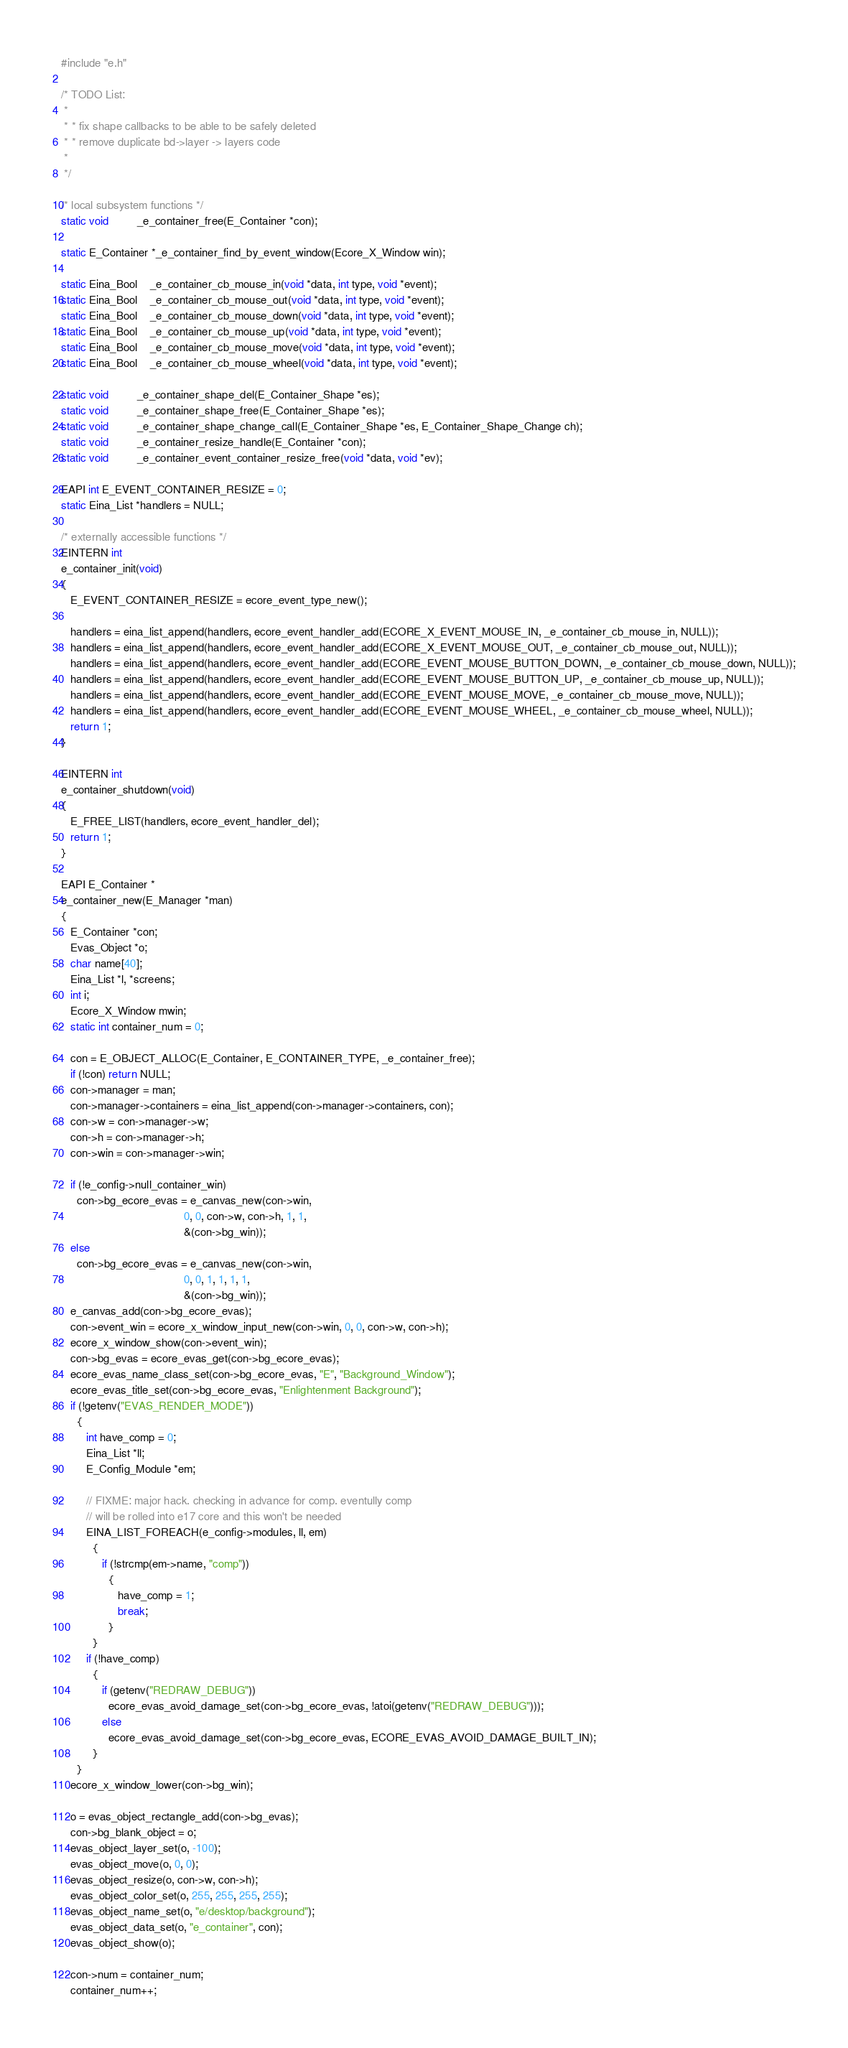Convert code to text. <code><loc_0><loc_0><loc_500><loc_500><_C_>#include "e.h"

/* TODO List:
 *
 * * fix shape callbacks to be able to be safely deleted
 * * remove duplicate bd->layer -> layers code
 *
 */

/* local subsystem functions */
static void         _e_container_free(E_Container *con);

static E_Container *_e_container_find_by_event_window(Ecore_X_Window win);

static Eina_Bool    _e_container_cb_mouse_in(void *data, int type, void *event);
static Eina_Bool    _e_container_cb_mouse_out(void *data, int type, void *event);
static Eina_Bool    _e_container_cb_mouse_down(void *data, int type, void *event);
static Eina_Bool    _e_container_cb_mouse_up(void *data, int type, void *event);
static Eina_Bool    _e_container_cb_mouse_move(void *data, int type, void *event);
static Eina_Bool    _e_container_cb_mouse_wheel(void *data, int type, void *event);

static void         _e_container_shape_del(E_Container_Shape *es);
static void         _e_container_shape_free(E_Container_Shape *es);
static void         _e_container_shape_change_call(E_Container_Shape *es, E_Container_Shape_Change ch);
static void         _e_container_resize_handle(E_Container *con);
static void         _e_container_event_container_resize_free(void *data, void *ev);

EAPI int E_EVENT_CONTAINER_RESIZE = 0;
static Eina_List *handlers = NULL;

/* externally accessible functions */
EINTERN int
e_container_init(void)
{
   E_EVENT_CONTAINER_RESIZE = ecore_event_type_new();

   handlers = eina_list_append(handlers, ecore_event_handler_add(ECORE_X_EVENT_MOUSE_IN, _e_container_cb_mouse_in, NULL));
   handlers = eina_list_append(handlers, ecore_event_handler_add(ECORE_X_EVENT_MOUSE_OUT, _e_container_cb_mouse_out, NULL));
   handlers = eina_list_append(handlers, ecore_event_handler_add(ECORE_EVENT_MOUSE_BUTTON_DOWN, _e_container_cb_mouse_down, NULL));
   handlers = eina_list_append(handlers, ecore_event_handler_add(ECORE_EVENT_MOUSE_BUTTON_UP, _e_container_cb_mouse_up, NULL));
   handlers = eina_list_append(handlers, ecore_event_handler_add(ECORE_EVENT_MOUSE_MOVE, _e_container_cb_mouse_move, NULL));
   handlers = eina_list_append(handlers, ecore_event_handler_add(ECORE_EVENT_MOUSE_WHEEL, _e_container_cb_mouse_wheel, NULL));
   return 1;
}

EINTERN int
e_container_shutdown(void)
{
   E_FREE_LIST(handlers, ecore_event_handler_del);
   return 1;
}

EAPI E_Container *
e_container_new(E_Manager *man)
{
   E_Container *con;
   Evas_Object *o;
   char name[40];
   Eina_List *l, *screens;
   int i;
   Ecore_X_Window mwin;
   static int container_num = 0;

   con = E_OBJECT_ALLOC(E_Container, E_CONTAINER_TYPE, _e_container_free);
   if (!con) return NULL;
   con->manager = man;
   con->manager->containers = eina_list_append(con->manager->containers, con);
   con->w = con->manager->w;
   con->h = con->manager->h;
   con->win = con->manager->win;

   if (!e_config->null_container_win)
     con->bg_ecore_evas = e_canvas_new(con->win,
                                       0, 0, con->w, con->h, 1, 1,
                                       &(con->bg_win));
   else
     con->bg_ecore_evas = e_canvas_new(con->win,
                                       0, 0, 1, 1, 1, 1,
                                       &(con->bg_win));
   e_canvas_add(con->bg_ecore_evas);
   con->event_win = ecore_x_window_input_new(con->win, 0, 0, con->w, con->h);
   ecore_x_window_show(con->event_win);
   con->bg_evas = ecore_evas_get(con->bg_ecore_evas);
   ecore_evas_name_class_set(con->bg_ecore_evas, "E", "Background_Window");
   ecore_evas_title_set(con->bg_ecore_evas, "Enlightenment Background");
   if (!getenv("EVAS_RENDER_MODE"))
     {
        int have_comp = 0;
        Eina_List *ll;
        E_Config_Module *em;

        // FIXME: major hack. checking in advance for comp. eventully comp
        // will be rolled into e17 core and this won't be needed
        EINA_LIST_FOREACH(e_config->modules, ll, em)
          {
             if (!strcmp(em->name, "comp"))
               {
                  have_comp = 1;
                  break;
               }
          }
        if (!have_comp)
          {
             if (getenv("REDRAW_DEBUG"))
               ecore_evas_avoid_damage_set(con->bg_ecore_evas, !atoi(getenv("REDRAW_DEBUG")));
             else
               ecore_evas_avoid_damage_set(con->bg_ecore_evas, ECORE_EVAS_AVOID_DAMAGE_BUILT_IN);
          }
     }
   ecore_x_window_lower(con->bg_win);

   o = evas_object_rectangle_add(con->bg_evas);
   con->bg_blank_object = o;
   evas_object_layer_set(o, -100);
   evas_object_move(o, 0, 0);
   evas_object_resize(o, con->w, con->h);
   evas_object_color_set(o, 255, 255, 255, 255);
   evas_object_name_set(o, "e/desktop/background");
   evas_object_data_set(o, "e_container", con);
   evas_object_show(o);

   con->num = container_num;
   container_num++;</code> 